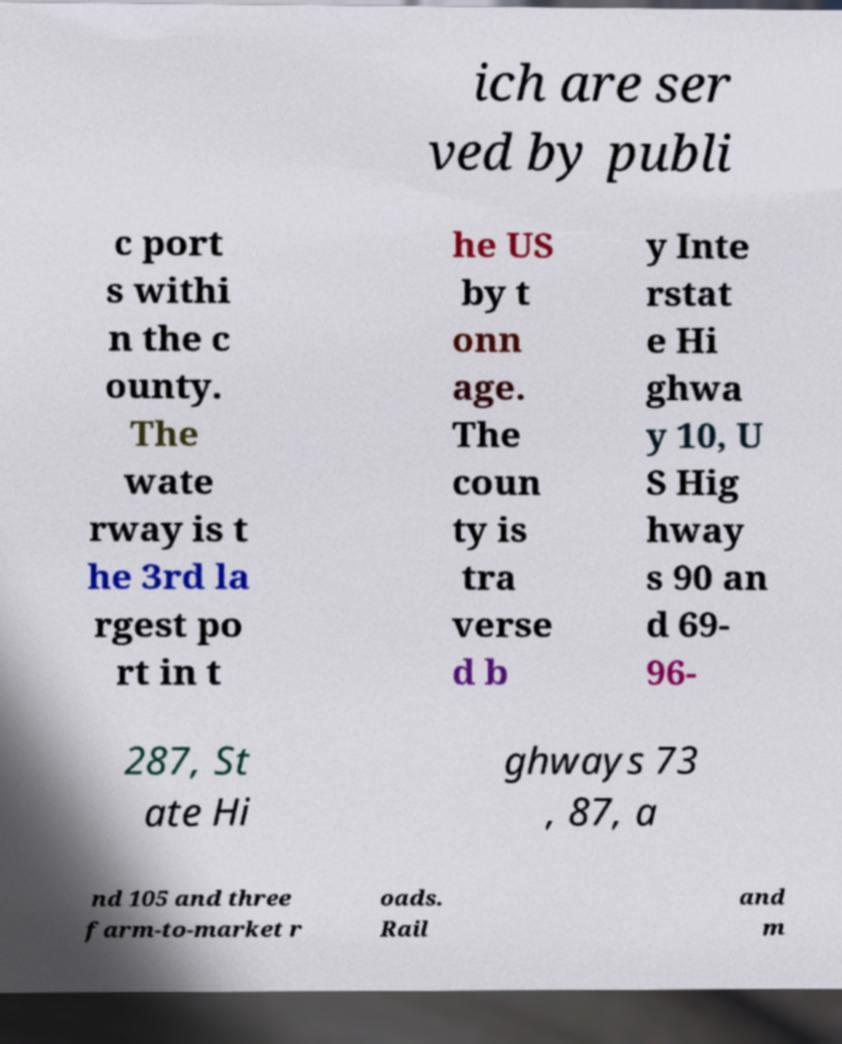Can you accurately transcribe the text from the provided image for me? ich are ser ved by publi c port s withi n the c ounty. The wate rway is t he 3rd la rgest po rt in t he US by t onn age. The coun ty is tra verse d b y Inte rstat e Hi ghwa y 10, U S Hig hway s 90 an d 69- 96- 287, St ate Hi ghways 73 , 87, a nd 105 and three farm-to-market r oads. Rail and m 